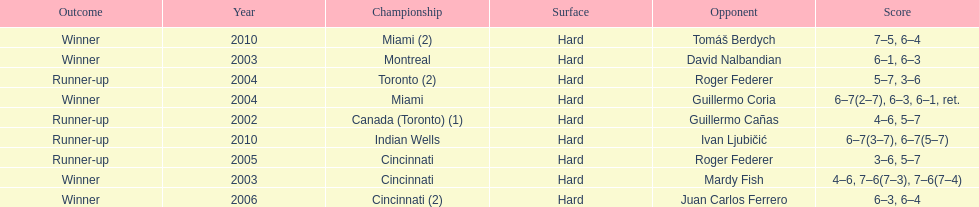How many championships occurred in toronto or montreal? 3. 